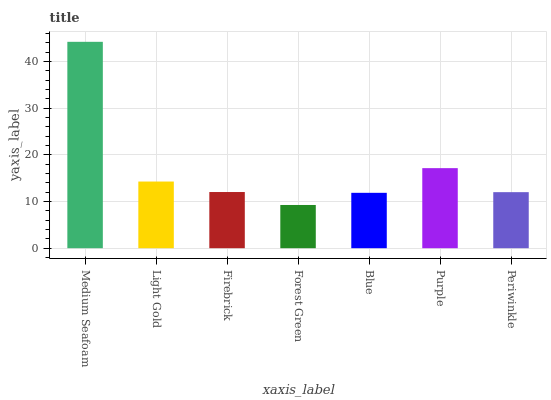Is Forest Green the minimum?
Answer yes or no. Yes. Is Medium Seafoam the maximum?
Answer yes or no. Yes. Is Light Gold the minimum?
Answer yes or no. No. Is Light Gold the maximum?
Answer yes or no. No. Is Medium Seafoam greater than Light Gold?
Answer yes or no. Yes. Is Light Gold less than Medium Seafoam?
Answer yes or no. Yes. Is Light Gold greater than Medium Seafoam?
Answer yes or no. No. Is Medium Seafoam less than Light Gold?
Answer yes or no. No. Is Firebrick the high median?
Answer yes or no. Yes. Is Firebrick the low median?
Answer yes or no. Yes. Is Periwinkle the high median?
Answer yes or no. No. Is Medium Seafoam the low median?
Answer yes or no. No. 